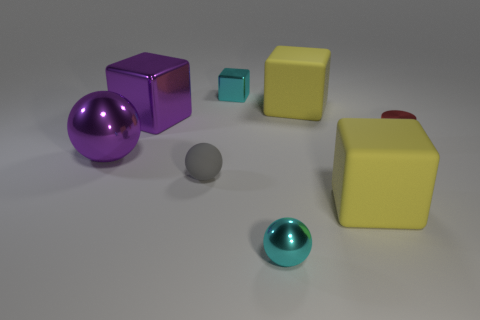Subtract all large purple cubes. How many cubes are left? 3 Add 1 small red matte balls. How many objects exist? 9 Subtract all cyan blocks. How many blocks are left? 3 Subtract all cylinders. How many objects are left? 7 Subtract 1 balls. How many balls are left? 2 Subtract all red balls. Subtract all blue blocks. How many balls are left? 3 Subtract all yellow cylinders. How many yellow blocks are left? 2 Subtract all tiny cylinders. Subtract all purple blocks. How many objects are left? 6 Add 4 tiny cyan shiny cubes. How many tiny cyan shiny cubes are left? 5 Add 4 big purple objects. How many big purple objects exist? 6 